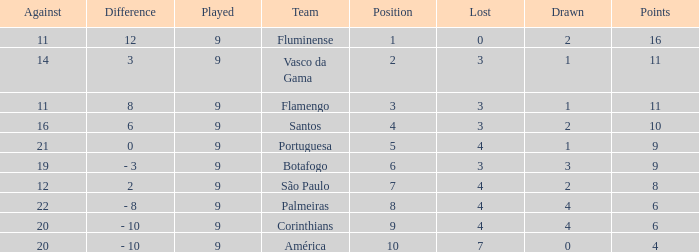Which Points is the highest one that has a Position of 1, and a Lost smaller than 0? None. 